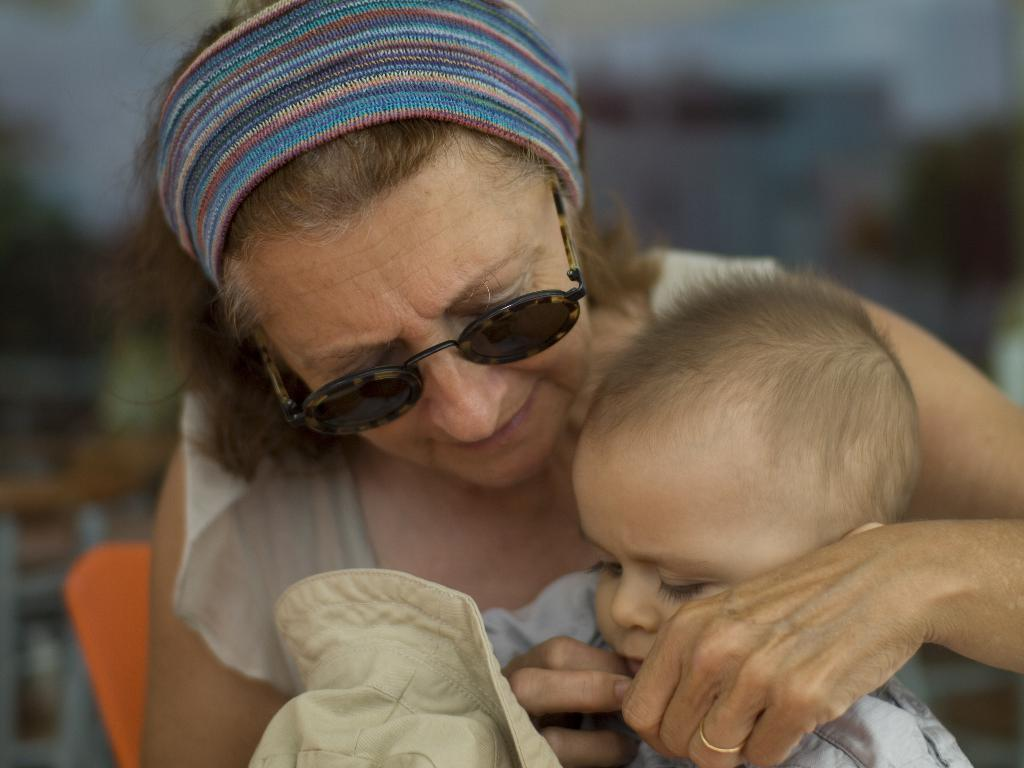Who is the main subject in the image? There is a woman in the image. What is the woman wearing on her head? The woman is wearing a headband. What type of eyewear is the woman wearing? The woman is wearing goggles. What is the woman doing with her hands? The woman is holding a kid in her hands. What is the kid holding? The kid is holding a hat. What type of nerve can be seen in the woman's wrist in the image? There is no nerve visible in the image, and the woman's wrist is not mentioned in the provided facts. How many dolls are present in the image? There is no mention of dolls in the provided facts, so it cannot be determined if any dolls are present in the image. 